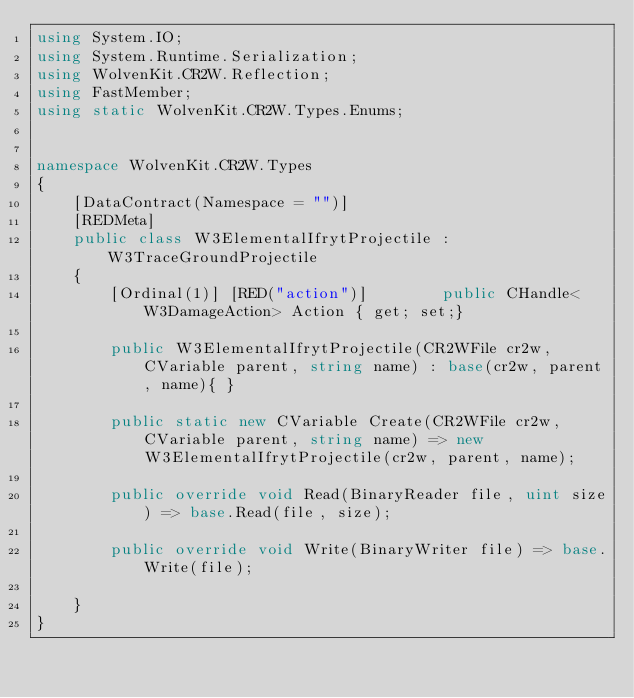Convert code to text. <code><loc_0><loc_0><loc_500><loc_500><_C#_>using System.IO;
using System.Runtime.Serialization;
using WolvenKit.CR2W.Reflection;
using FastMember;
using static WolvenKit.CR2W.Types.Enums;


namespace WolvenKit.CR2W.Types
{
	[DataContract(Namespace = "")]
	[REDMeta]
	public class W3ElementalIfrytProjectile : W3TraceGroundProjectile
	{
		[Ordinal(1)] [RED("action")] 		public CHandle<W3DamageAction> Action { get; set;}

		public W3ElementalIfrytProjectile(CR2WFile cr2w, CVariable parent, string name) : base(cr2w, parent, name){ }

		public static new CVariable Create(CR2WFile cr2w, CVariable parent, string name) => new W3ElementalIfrytProjectile(cr2w, parent, name);

		public override void Read(BinaryReader file, uint size) => base.Read(file, size);

		public override void Write(BinaryWriter file) => base.Write(file);

	}
}</code> 